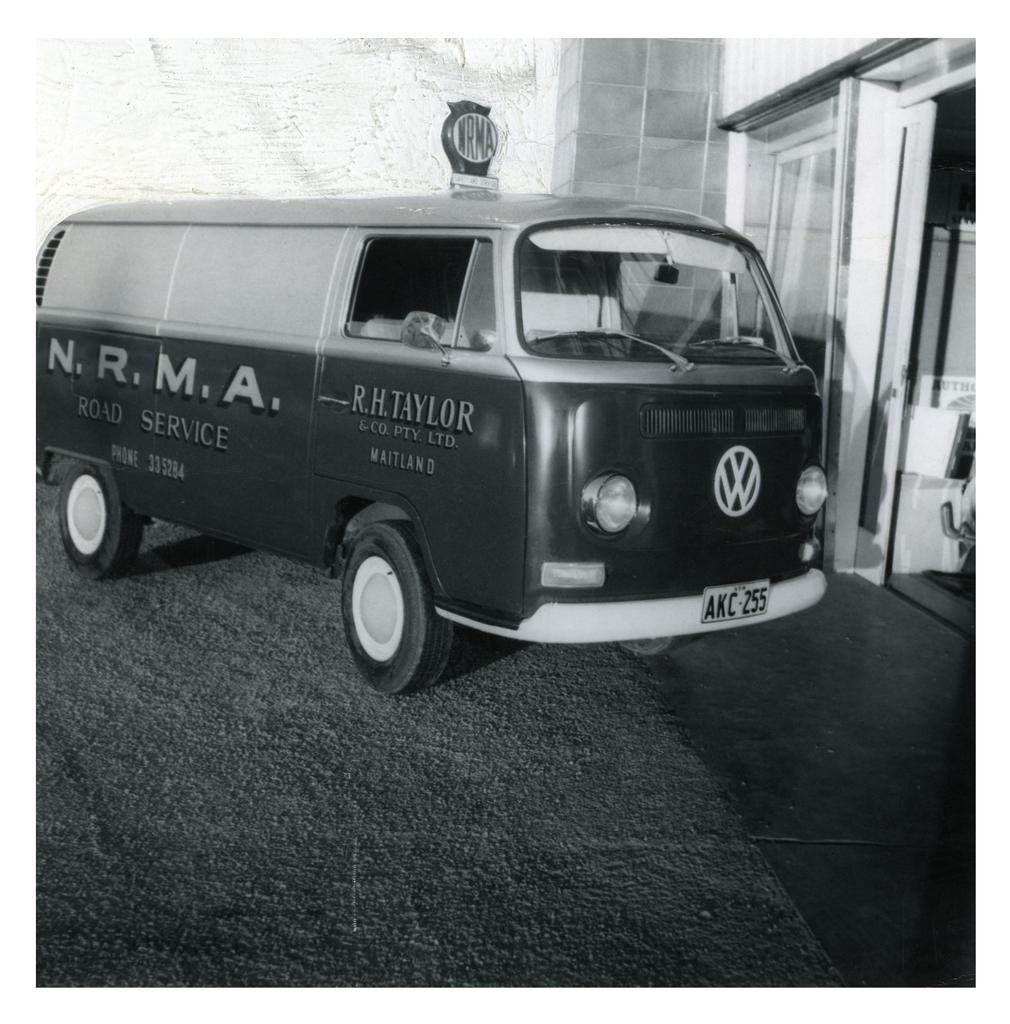Who's name is on the bus?
Your answer should be very brief. R.h. taylor. What is the lisencse number?
Offer a terse response. Akc 255. 